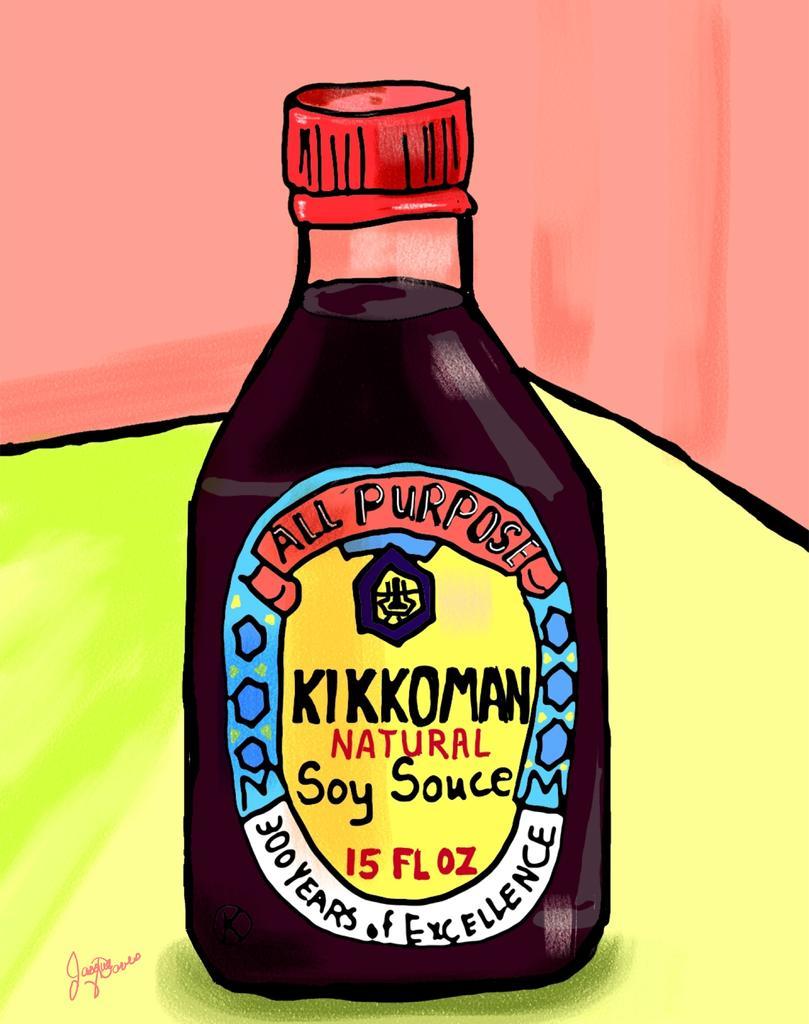What brand of soy sauce?
Make the answer very short. Kikkoman. How many ounces are in this bottle?
Offer a terse response. 15. 